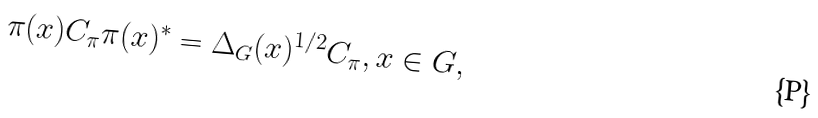<formula> <loc_0><loc_0><loc_500><loc_500>\pi ( x ) C _ { \pi } \pi ( x ) ^ { * } = \Delta _ { G } ( x ) ^ { 1 / 2 } C _ { \pi } , x \in G ,</formula> 